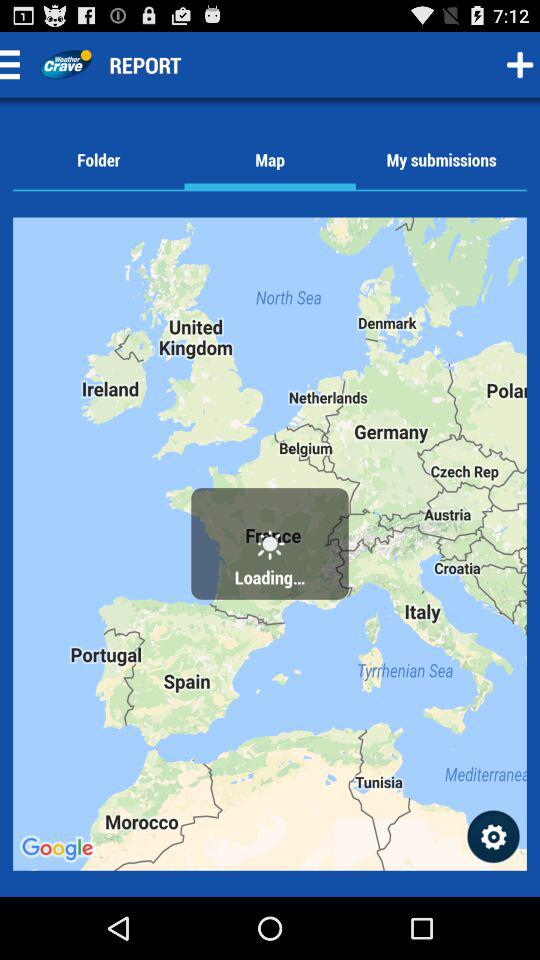Which tab is selected? The selected tab is "Map". 